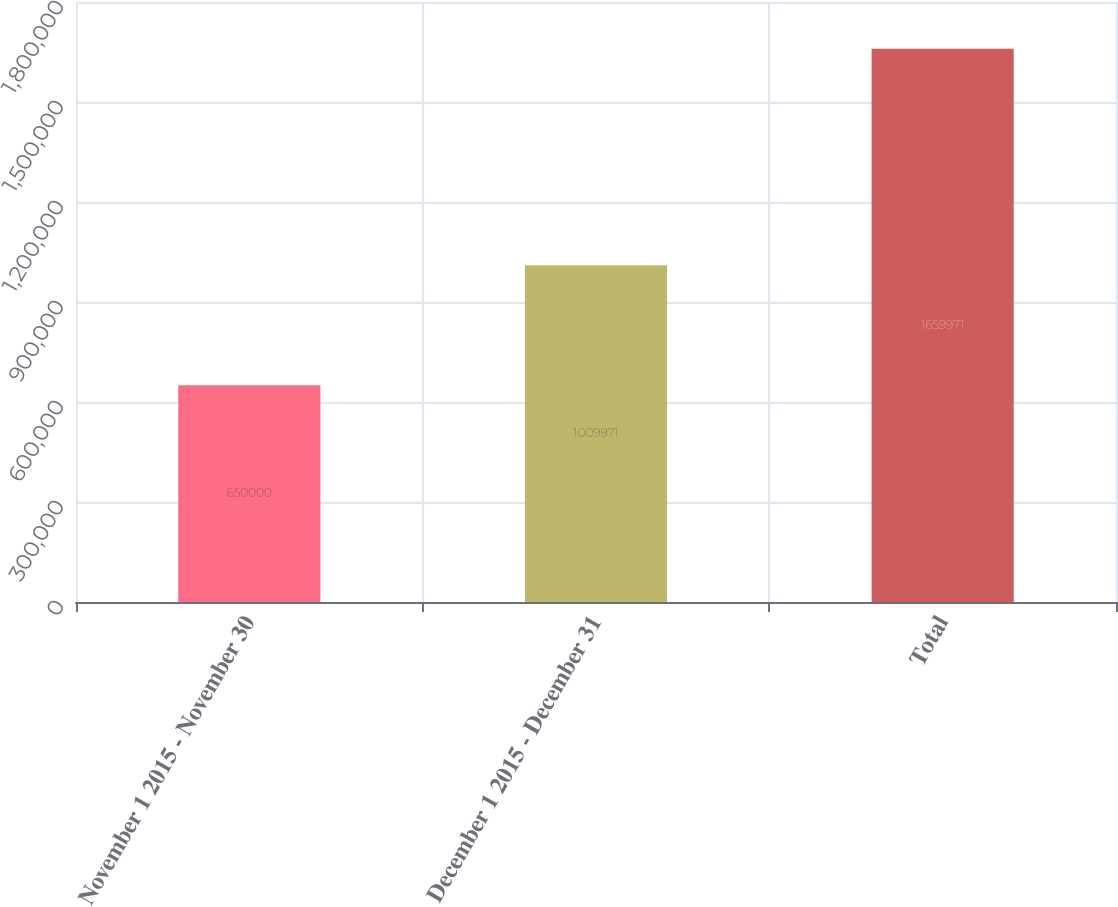<chart> <loc_0><loc_0><loc_500><loc_500><bar_chart><fcel>November 1 2015 - November 30<fcel>December 1 2015 - December 31<fcel>Total<nl><fcel>650000<fcel>1.00997e+06<fcel>1.65997e+06<nl></chart> 